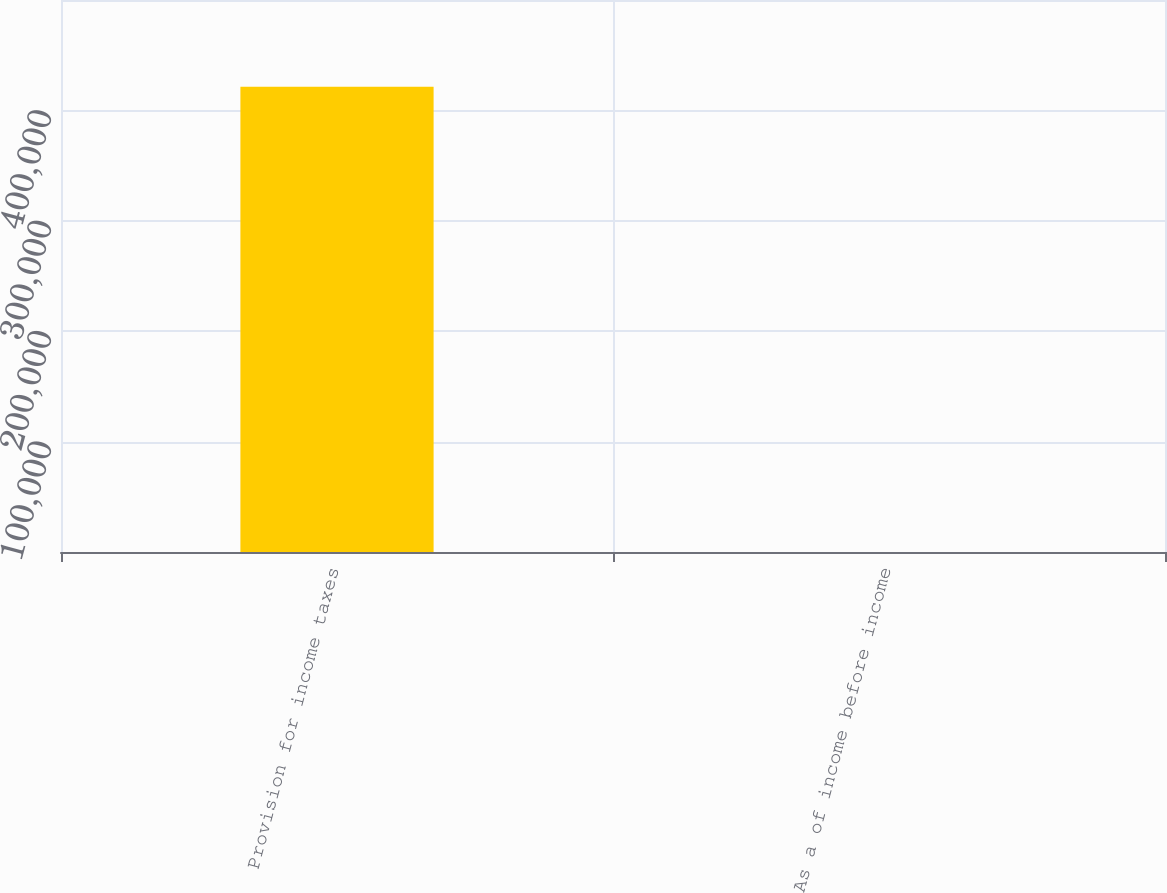Convert chart. <chart><loc_0><loc_0><loc_500><loc_500><bar_chart><fcel>Provision for income taxes<fcel>As a of income before income<nl><fcel>421418<fcel>27<nl></chart> 